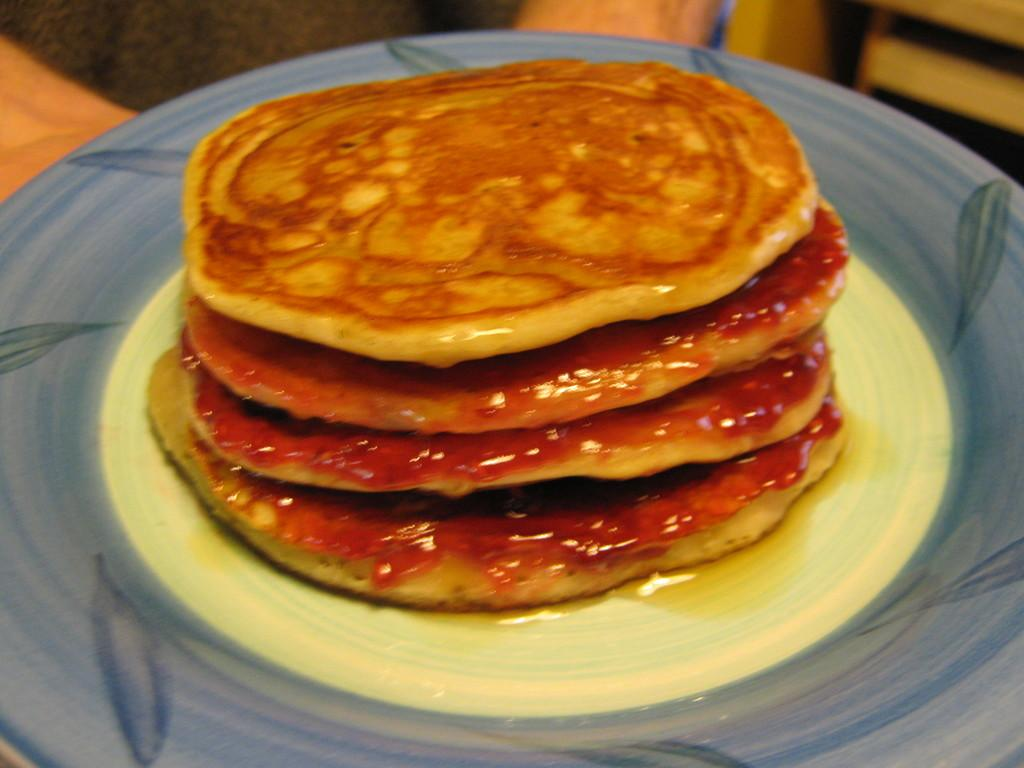What is on the plate that is visible in the image? There are pancakes on the plate in the image. Can you describe the main subject of the image? The main subject of the image is a plate with pancakes on it. What type of rail can be seen in the image? There is no rail present in the image; it only features a plate with pancakes on it. 